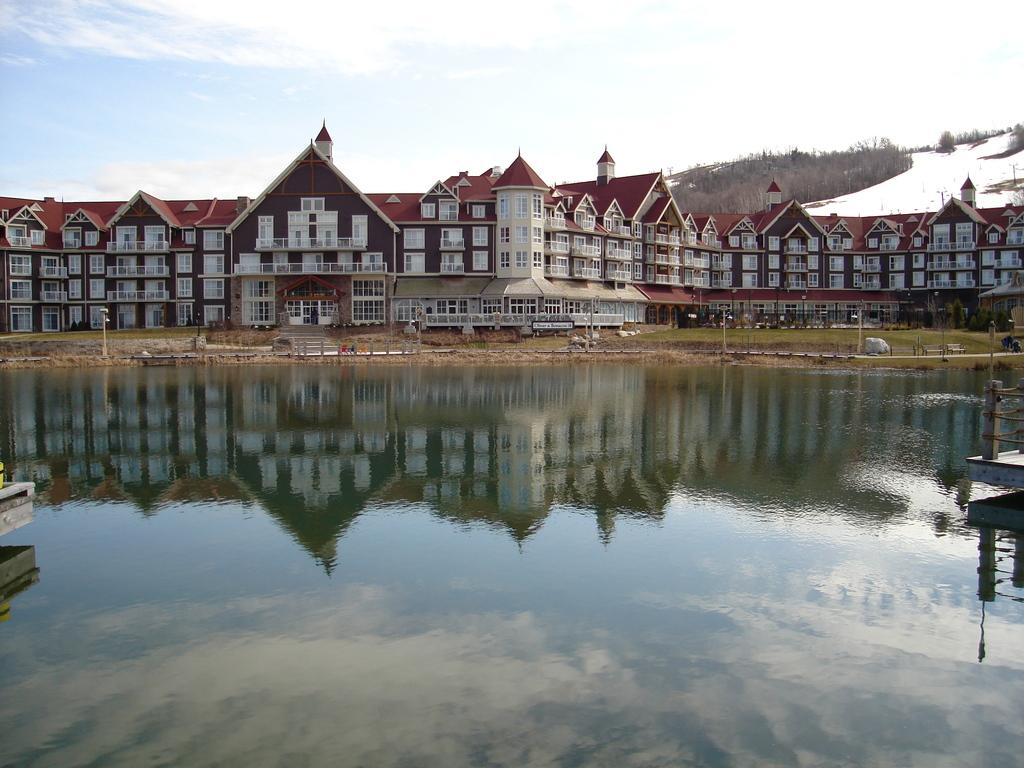What is located at the bottom of the image? There is water at the bottom of the image. What structures can be seen in the middle of the image? There are buildings in the middle of the image. What is visible at the top of the image? The sky is visible at the top of the image. How would you describe the sky in the image? The sky appears to be cloudy. How many roses can be seen growing near the buildings in the image? There are no roses present in the image; it features water, buildings, and a cloudy sky. Can you hear the bells ringing in the image? There are no bells present in the image, so it is not possible to hear them ringing. 